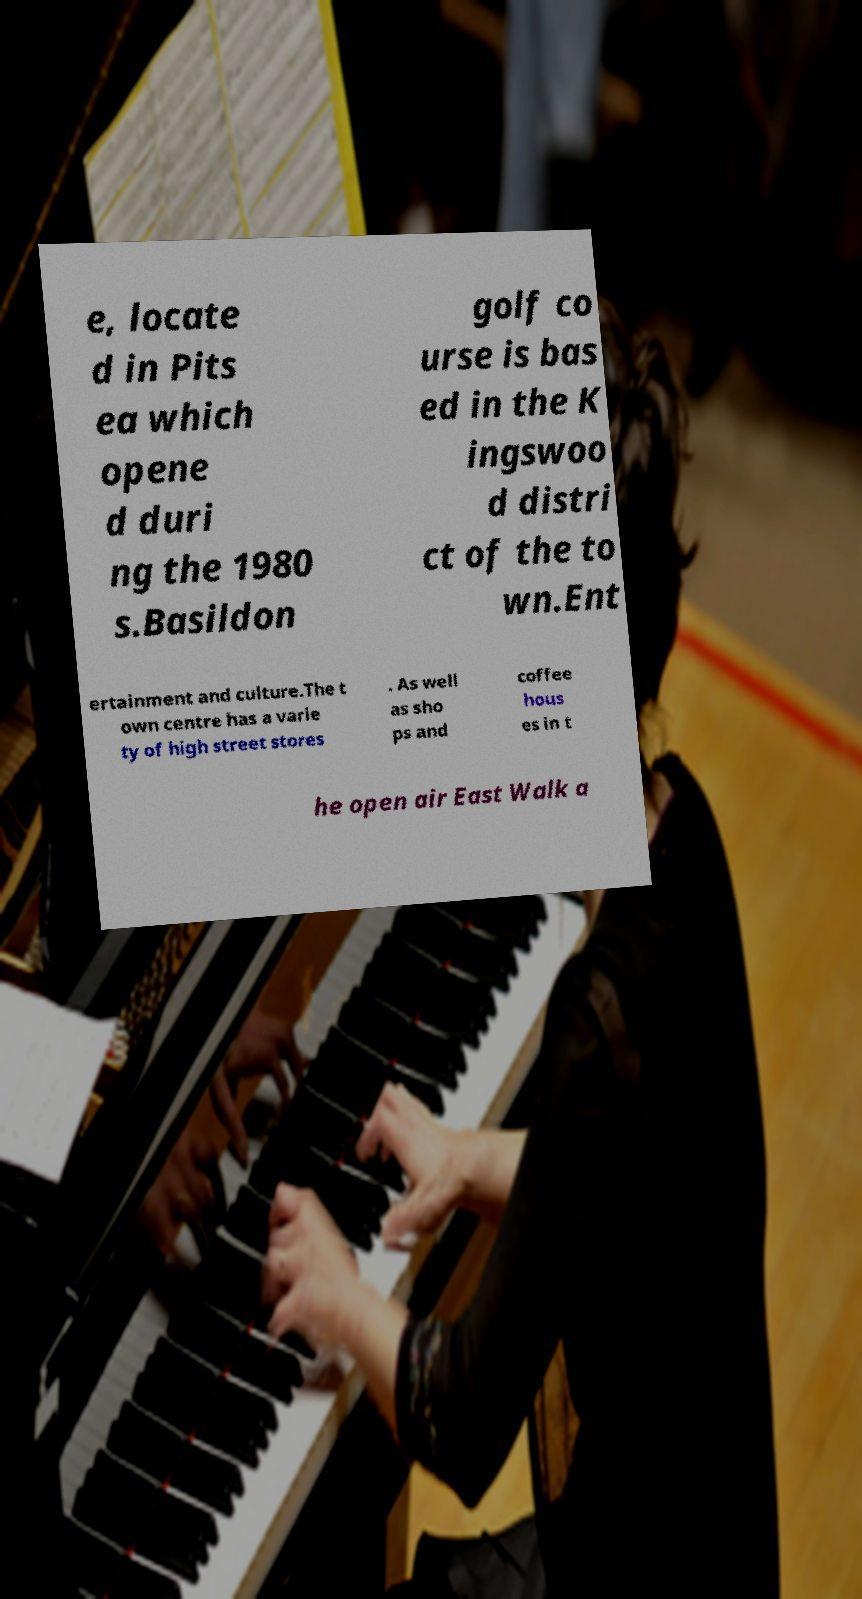Could you extract and type out the text from this image? e, locate d in Pits ea which opene d duri ng the 1980 s.Basildon golf co urse is bas ed in the K ingswoo d distri ct of the to wn.Ent ertainment and culture.The t own centre has a varie ty of high street stores . As well as sho ps and coffee hous es in t he open air East Walk a 